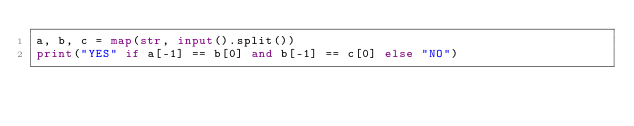<code> <loc_0><loc_0><loc_500><loc_500><_Python_>a, b, c = map(str, input().split())
print("YES" if a[-1] == b[0] and b[-1] == c[0] else "NO")</code> 